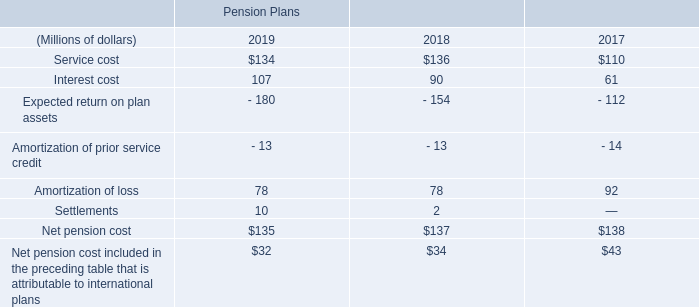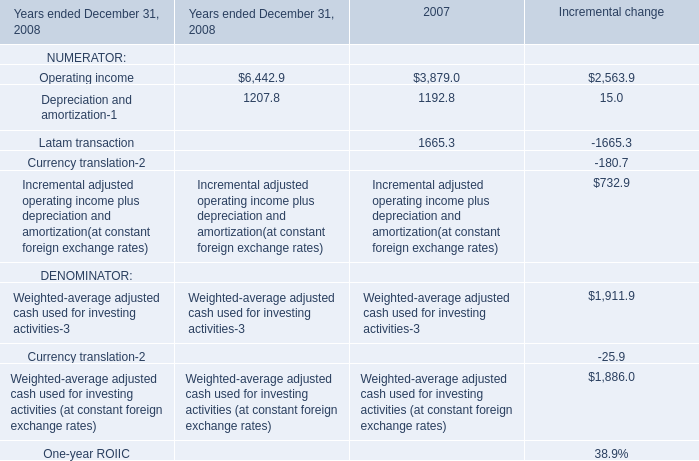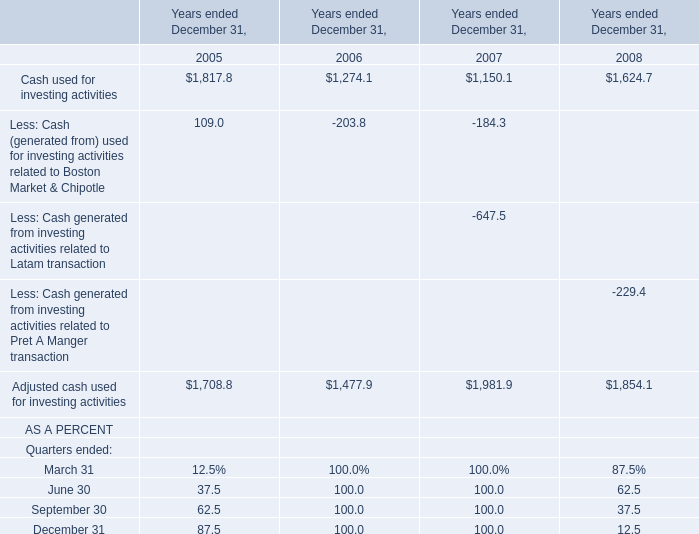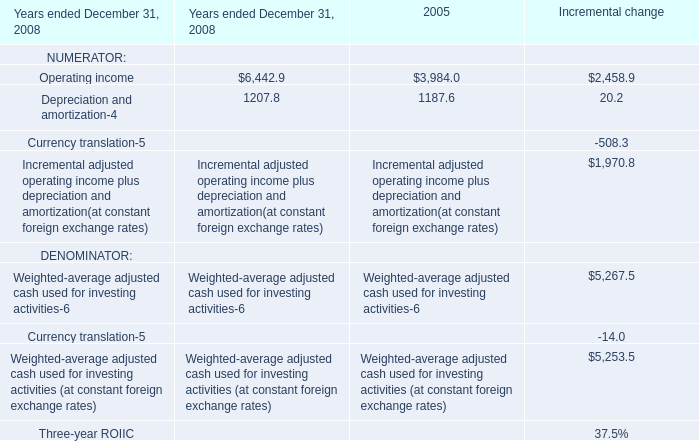What's the average of Operating income of 2005, and Operating income of 2007 ? 
Computations: ((3984.0 + 3879.0) / 2)
Answer: 3931.5. 